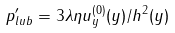Convert formula to latex. <formula><loc_0><loc_0><loc_500><loc_500>p _ { l u b } ^ { \prime } = 3 \lambda \eta u _ { y } ^ { ( 0 ) } ( y ) / h ^ { 2 } ( y )</formula> 